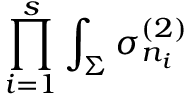Convert formula to latex. <formula><loc_0><loc_0><loc_500><loc_500>\prod _ { i = 1 } ^ { s } \int _ { \Sigma } \sigma _ { n _ { i } } ^ { ( 2 ) }</formula> 